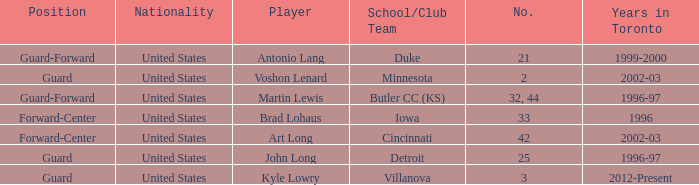What player played guard for toronto in 1996-97? John Long. 